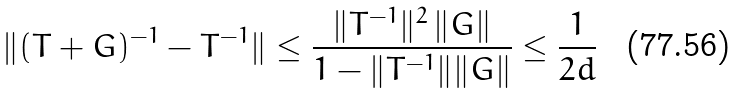<formula> <loc_0><loc_0><loc_500><loc_500>\| ( T + G ) ^ { - 1 } - T ^ { - 1 } \| \leq \frac { \| T ^ { - 1 } \| ^ { 2 } \, \| G \| } { 1 - \| T ^ { - 1 } \| \| G \| } \leq \frac { 1 } { 2 d }</formula> 